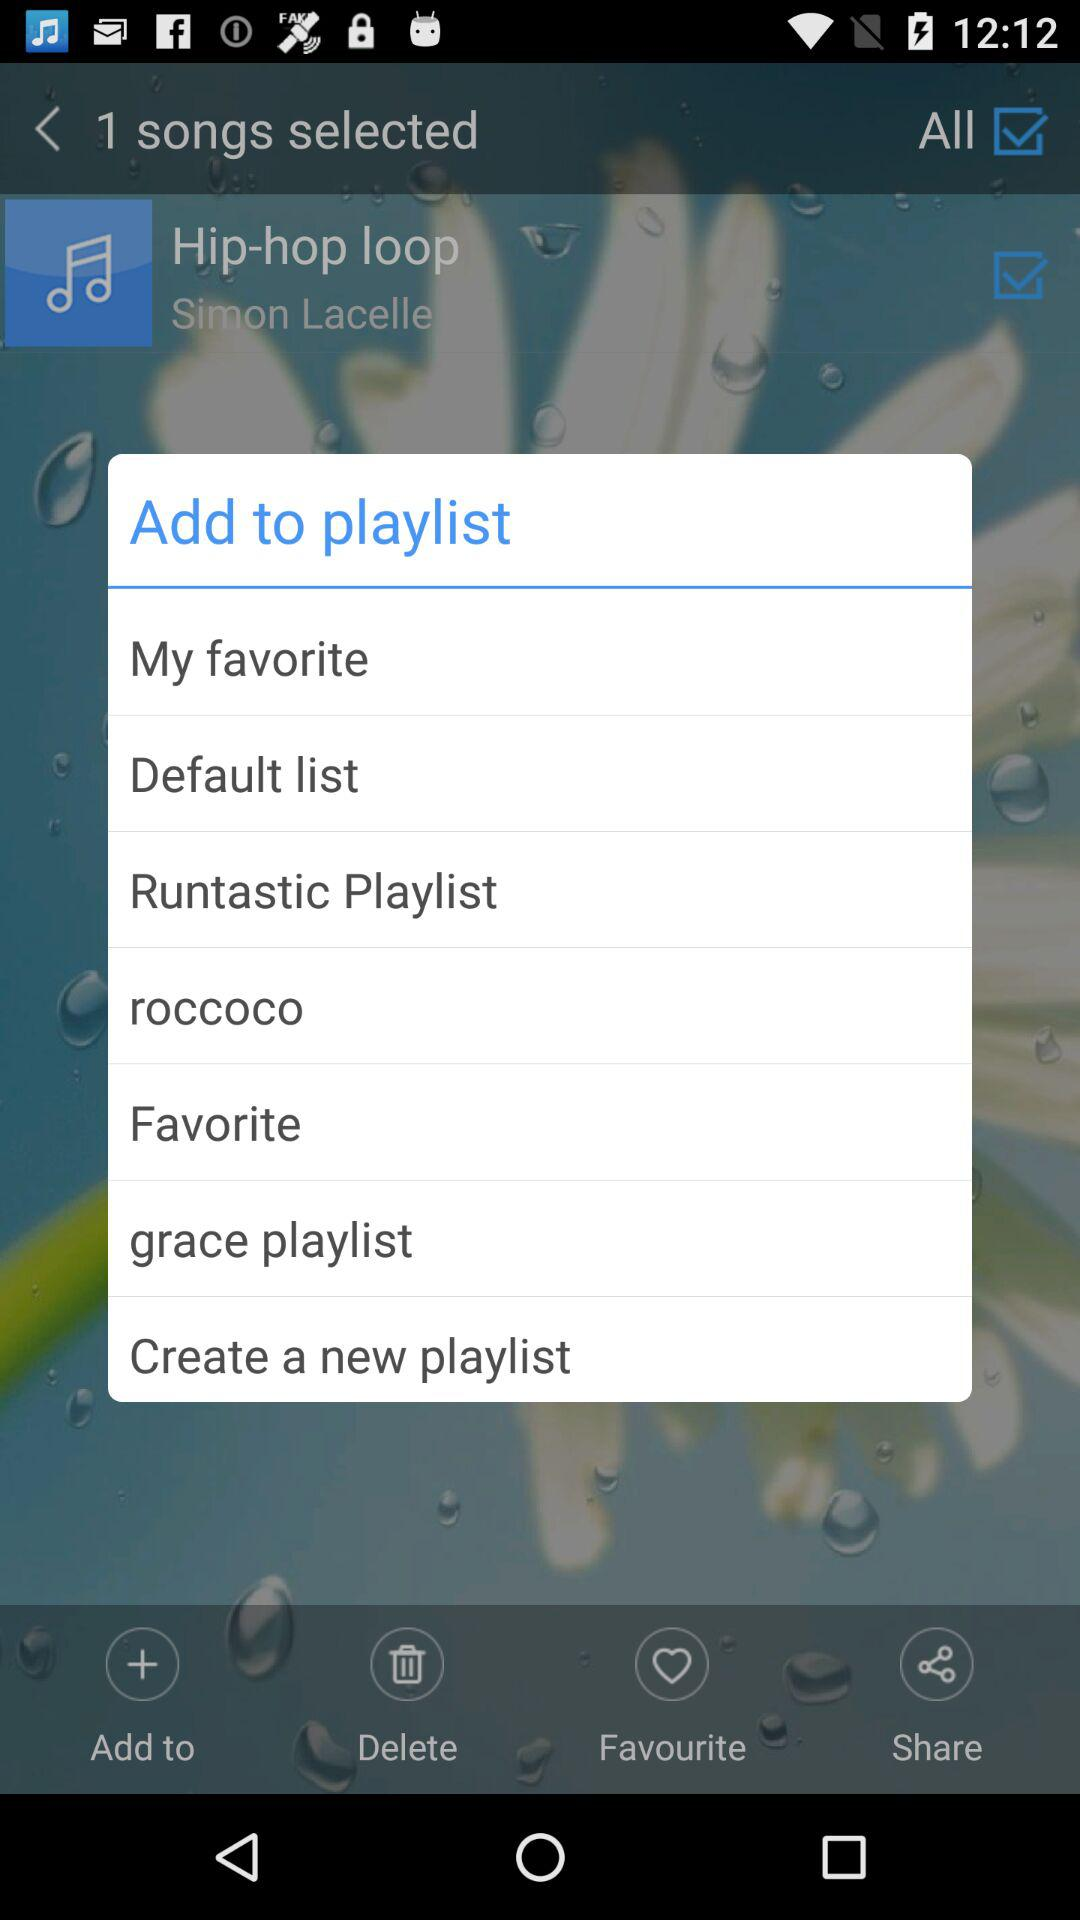What is the name of the song? The name of the song is "Hip-hop loop". 